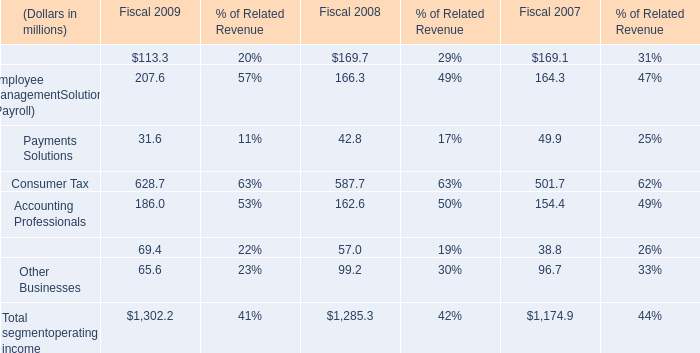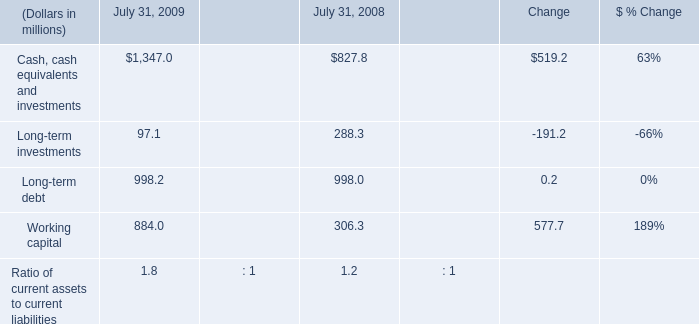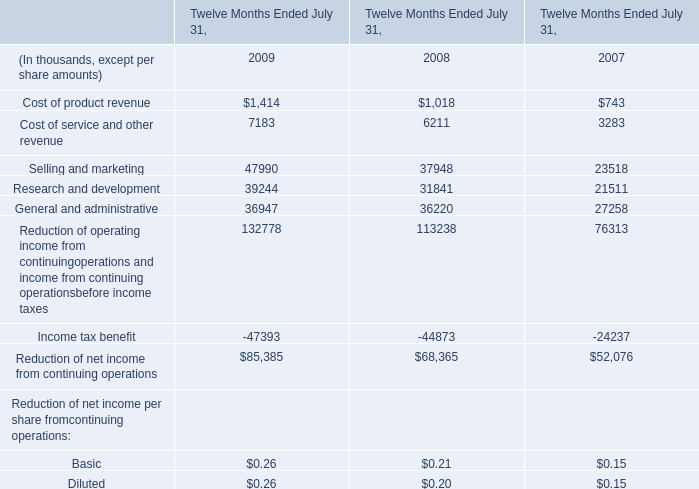What's the average of Cash, cash equivalents and investments of July 31, 2009, and General and administrative of Twelve Months Ended July 31, 2008 ? 
Computations: ((1347.0 + 36220.0) / 2)
Answer: 18783.5. 